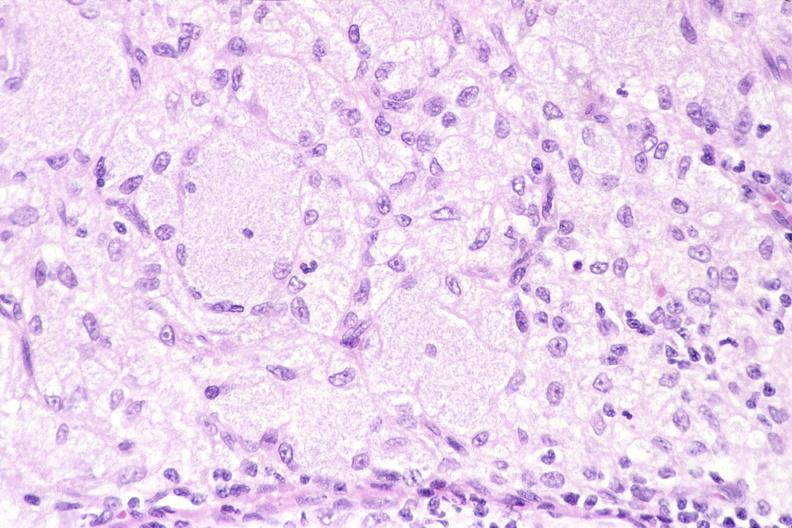does this image show lymph node, mycobacterium avium-intracellularae?
Answer the question using a single word or phrase. Yes 